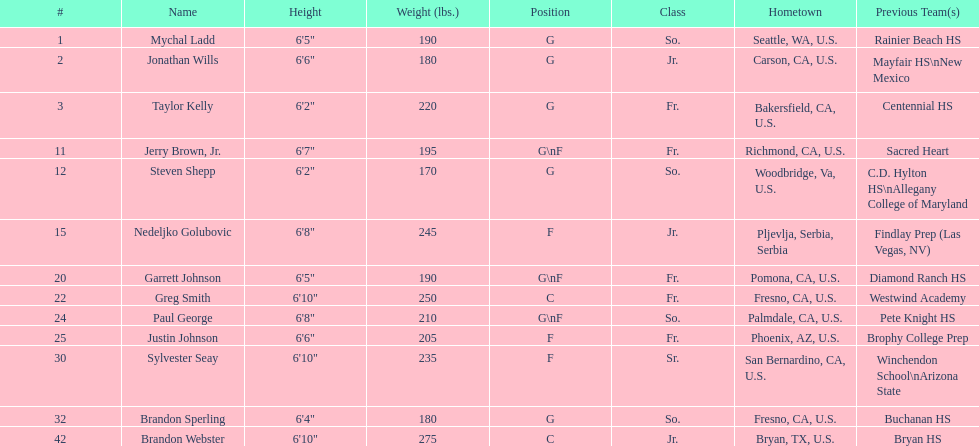Would you mind parsing the complete table? {'header': ['#', 'Name', 'Height', 'Weight (lbs.)', 'Position', 'Class', 'Hometown', 'Previous Team(s)'], 'rows': [['1', 'Mychal Ladd', '6\'5"', '190', 'G', 'So.', 'Seattle, WA, U.S.', 'Rainier Beach HS'], ['2', 'Jonathan Wills', '6\'6"', '180', 'G', 'Jr.', 'Carson, CA, U.S.', 'Mayfair HS\\nNew Mexico'], ['3', 'Taylor Kelly', '6\'2"', '220', 'G', 'Fr.', 'Bakersfield, CA, U.S.', 'Centennial HS'], ['11', 'Jerry Brown, Jr.', '6\'7"', '195', 'G\\nF', 'Fr.', 'Richmond, CA, U.S.', 'Sacred Heart'], ['12', 'Steven Shepp', '6\'2"', '170', 'G', 'So.', 'Woodbridge, Va, U.S.', 'C.D. Hylton HS\\nAllegany College of Maryland'], ['15', 'Nedeljko Golubovic', '6\'8"', '245', 'F', 'Jr.', 'Pljevlja, Serbia, Serbia', 'Findlay Prep (Las Vegas, NV)'], ['20', 'Garrett Johnson', '6\'5"', '190', 'G\\nF', 'Fr.', 'Pomona, CA, U.S.', 'Diamond Ranch HS'], ['22', 'Greg Smith', '6\'10"', '250', 'C', 'Fr.', 'Fresno, CA, U.S.', 'Westwind Academy'], ['24', 'Paul George', '6\'8"', '210', 'G\\nF', 'So.', 'Palmdale, CA, U.S.', 'Pete Knight HS'], ['25', 'Justin Johnson', '6\'6"', '205', 'F', 'Fr.', 'Phoenix, AZ, U.S.', 'Brophy College Prep'], ['30', 'Sylvester Seay', '6\'10"', '235', 'F', 'Sr.', 'San Bernardino, CA, U.S.', 'Winchendon School\\nArizona State'], ['32', 'Brandon Sperling', '6\'4"', '180', 'G', 'So.', 'Fresno, CA, U.S.', 'Buchanan HS'], ['42', 'Brandon Webster', '6\'10"', '275', 'C', 'Jr.', 'Bryan, TX, U.S.', 'Bryan HS']]} How many players' birthplaces are not in california? 5. 